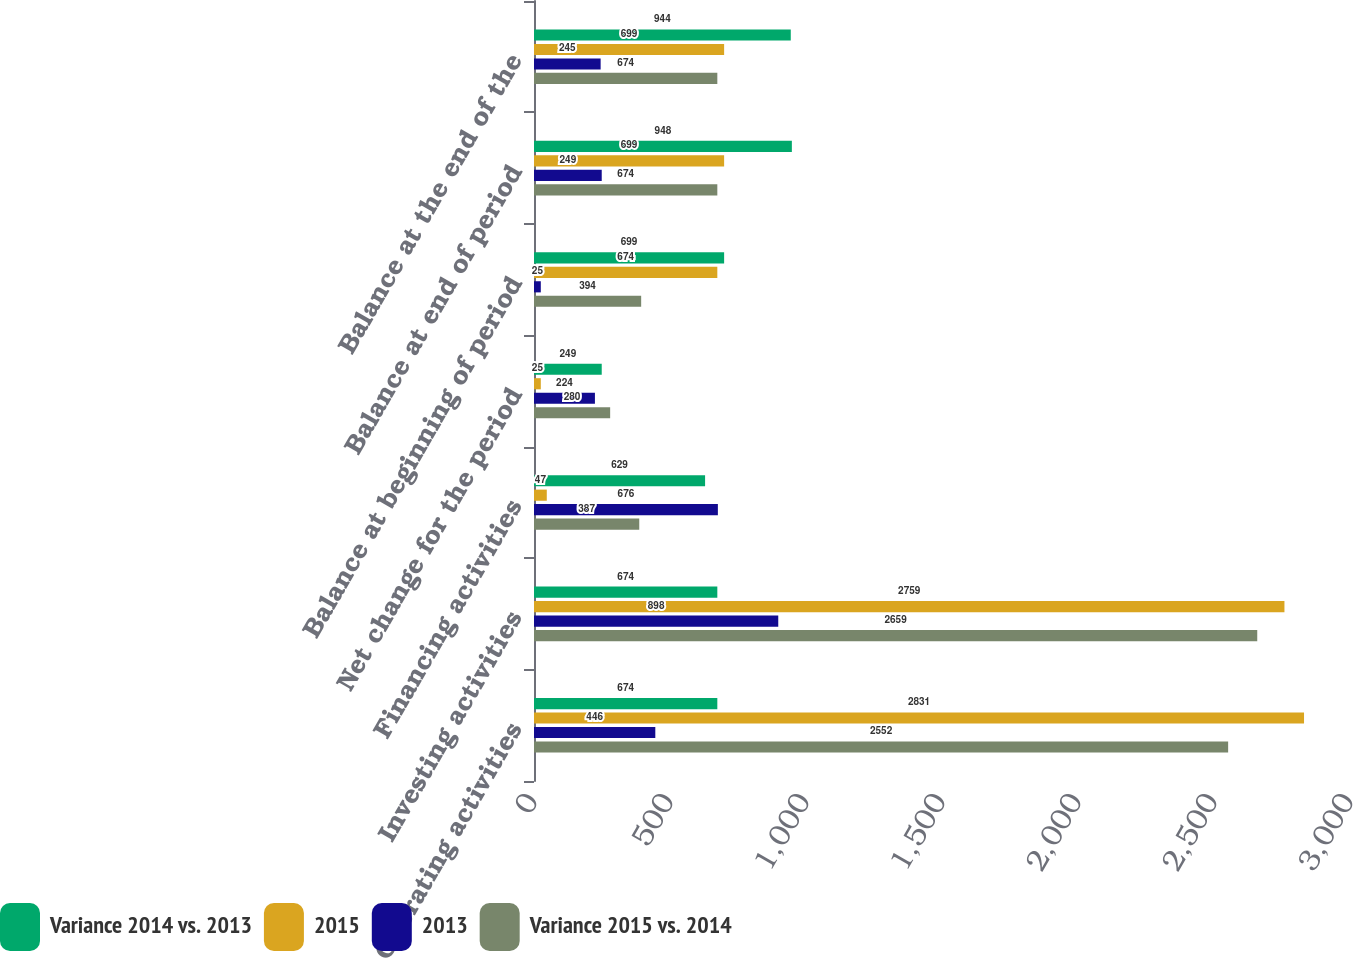Convert chart. <chart><loc_0><loc_0><loc_500><loc_500><stacked_bar_chart><ecel><fcel>Operating activities<fcel>Investing activities<fcel>Financing activities<fcel>Net change for the period<fcel>Balance at beginning of period<fcel>Balance at end of period<fcel>Balance at the end of the<nl><fcel>Variance 2014 vs. 2013<fcel>674<fcel>674<fcel>629<fcel>249<fcel>699<fcel>948<fcel>944<nl><fcel>2015<fcel>2831<fcel>2759<fcel>47<fcel>25<fcel>674<fcel>699<fcel>699<nl><fcel>2013<fcel>446<fcel>898<fcel>676<fcel>224<fcel>25<fcel>249<fcel>245<nl><fcel>Variance 2015 vs. 2014<fcel>2552<fcel>2659<fcel>387<fcel>280<fcel>394<fcel>674<fcel>674<nl></chart> 